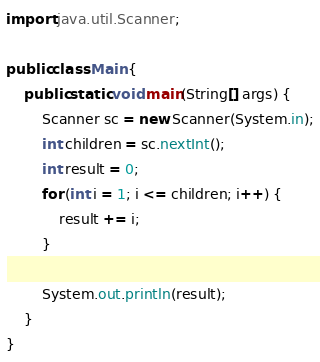Convert code to text. <code><loc_0><loc_0><loc_500><loc_500><_Java_>import java.util.Scanner;

public class Main {
    public static void main(String[] args) {
        Scanner sc = new Scanner(System.in);
        int children = sc.nextInt();
        int result = 0;
        for (int i = 1; i <= children; i++) {
            result += i;
        }
        
        System.out.println(result);
    }
}</code> 